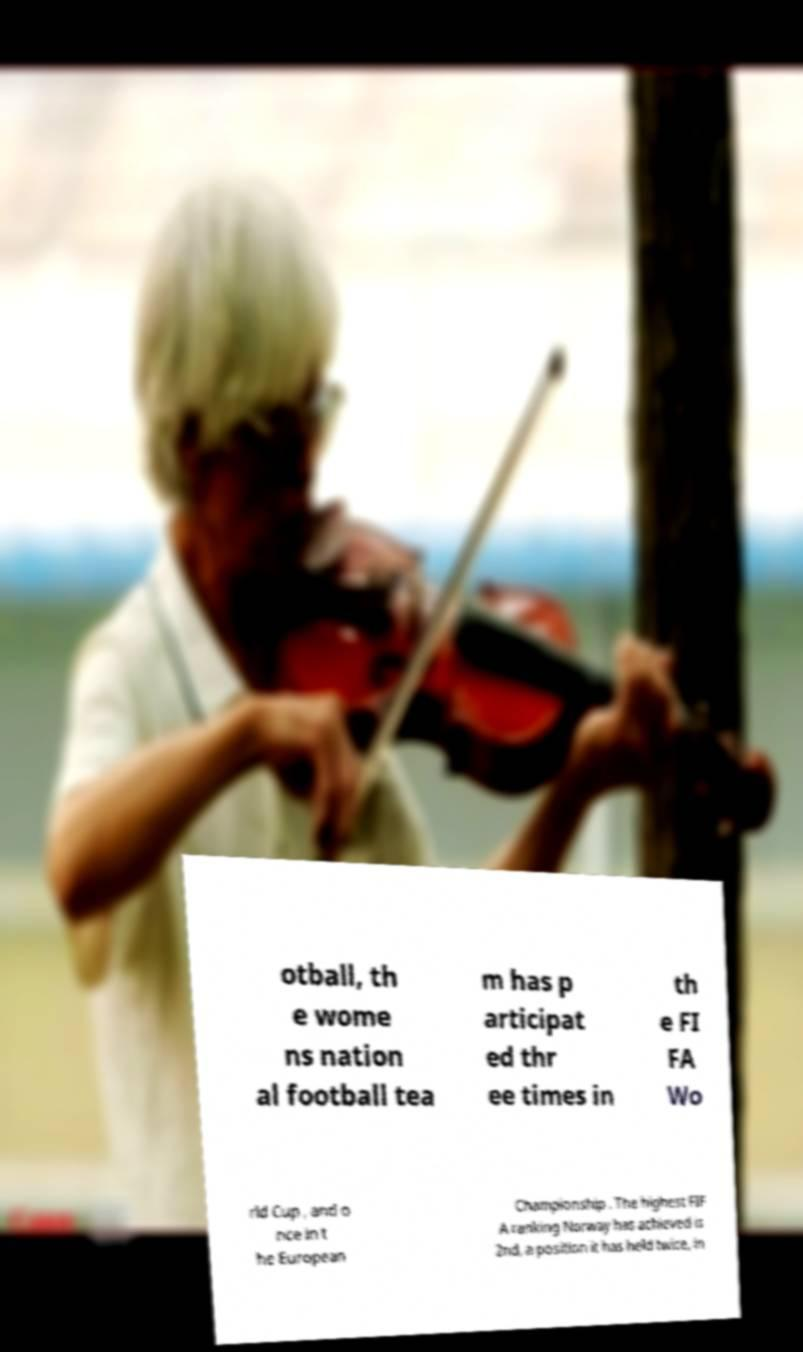Please identify and transcribe the text found in this image. otball, th e wome ns nation al football tea m has p articipat ed thr ee times in th e FI FA Wo rld Cup , and o nce in t he European Championship . The highest FIF A ranking Norway has achieved is 2nd, a position it has held twice, in 